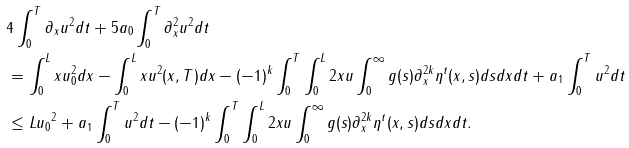<formula> <loc_0><loc_0><loc_500><loc_500>& 4 \int _ { 0 } ^ { T } \| \partial _ { x } u \| ^ { 2 } d t + 5 a _ { 0 } \int _ { 0 } ^ { T } \| \partial _ { x } ^ { 2 } u \| ^ { 2 } d t \\ & = \int _ { 0 } ^ { L } x u _ { 0 } ^ { 2 } d x - \int _ { 0 } ^ { L } x u ^ { 2 } ( x , T ) d x - ( - 1 ) ^ { k } \int _ { 0 } ^ { T } \int _ { 0 } ^ { L } 2 x u \int _ { 0 } ^ { \infty } g ( s ) \partial _ { x } ^ { 2 k } \eta ^ { t } ( x , s ) d s d x d t + a _ { 1 } \int _ { 0 } ^ { T } \| u \| ^ { 2 } d t \\ & \leq L \| u _ { 0 } \| ^ { 2 } + a _ { 1 } \int _ { 0 } ^ { T } \| u \| ^ { 2 } d t - ( - 1 ) ^ { k } \int _ { 0 } ^ { T } \int _ { 0 } ^ { L } 2 x u \int _ { 0 } ^ { \infty } g ( s ) \partial _ { x } ^ { 2 k } \eta ^ { t } ( x , s ) d s d x d t .</formula> 